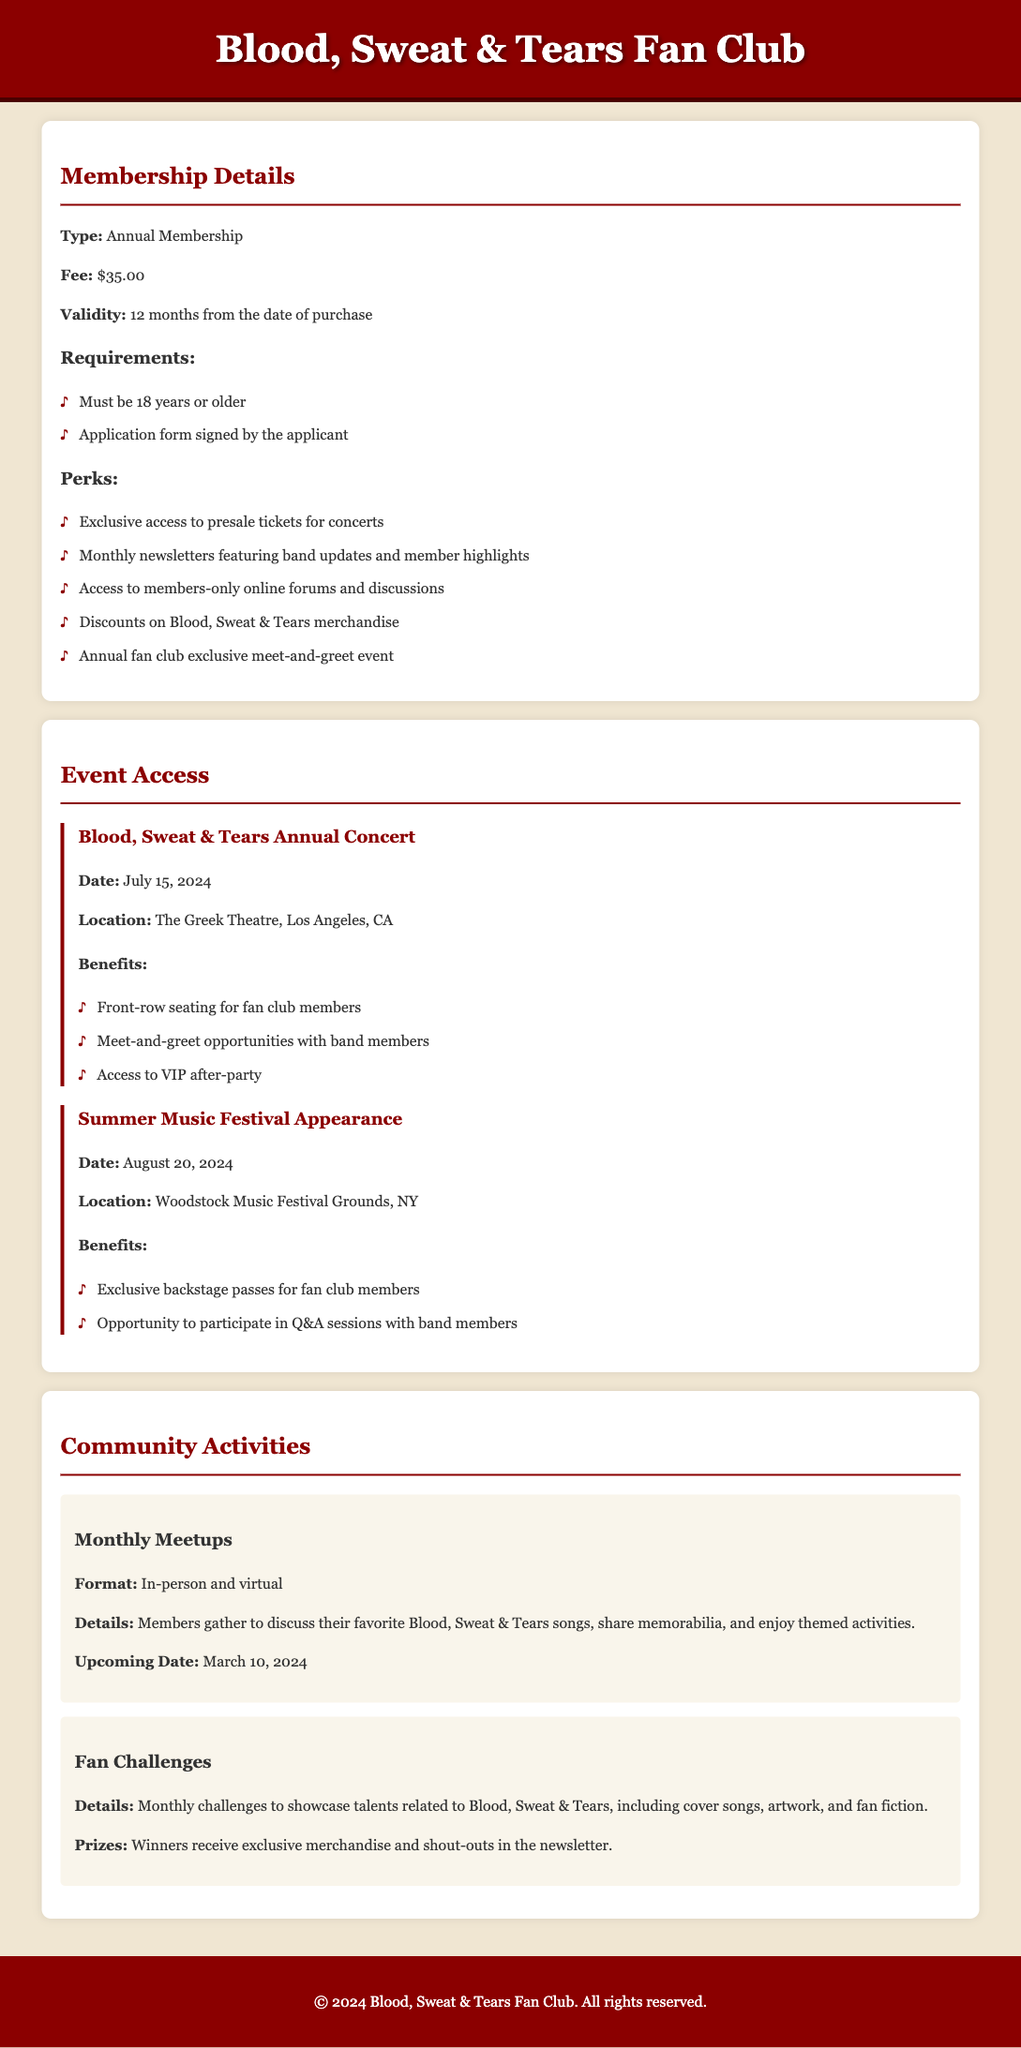What is the membership fee? The fee for the annual membership is listed under membership details as $35.00.
Answer: $35.00 How long is the membership valid? The validity period for the membership is specified as 12 months from the date of purchase.
Answer: 12 months What is a perk of joining the fan club? One of the perks mentioned is exclusive access to presale tickets for concerts, listed under perks.
Answer: Exclusive access to presale tickets for concerts When is the Blood, Sweat & Tears Annual Concert? The date for the concert event is provided in the event access section as July 15, 2024.
Answer: July 15, 2024 What type of activities are included in the community events? The document describes monthly meetups and fan challenges under community activities.
Answer: Monthly meetups and fan challenges What is a benefit of the Summer Music Festival Appearance? A benefit mentioned for the summer festival is exclusive backstage passes for fan club members.
Answer: Exclusive backstage passes for fan club members Who can join the fan club? The membership requirements specify that members must be 18 years or older.
Answer: 18 years or older What will members receive for winning monthly challenges? The document states that winners of the challenges receive exclusive merchandise and shout-outs in the newsletter.
Answer: Exclusive merchandise and shout-outs in the newsletter What is the location of the Blood, Sweat & Tears Annual Concert? The location for the concert is mentioned as The Greek Theatre, Los Angeles, CA.
Answer: The Greek Theatre, Los Angeles, CA 